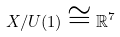<formula> <loc_0><loc_0><loc_500><loc_500>X / U ( 1 ) \cong \mathbb { R } ^ { 7 }</formula> 